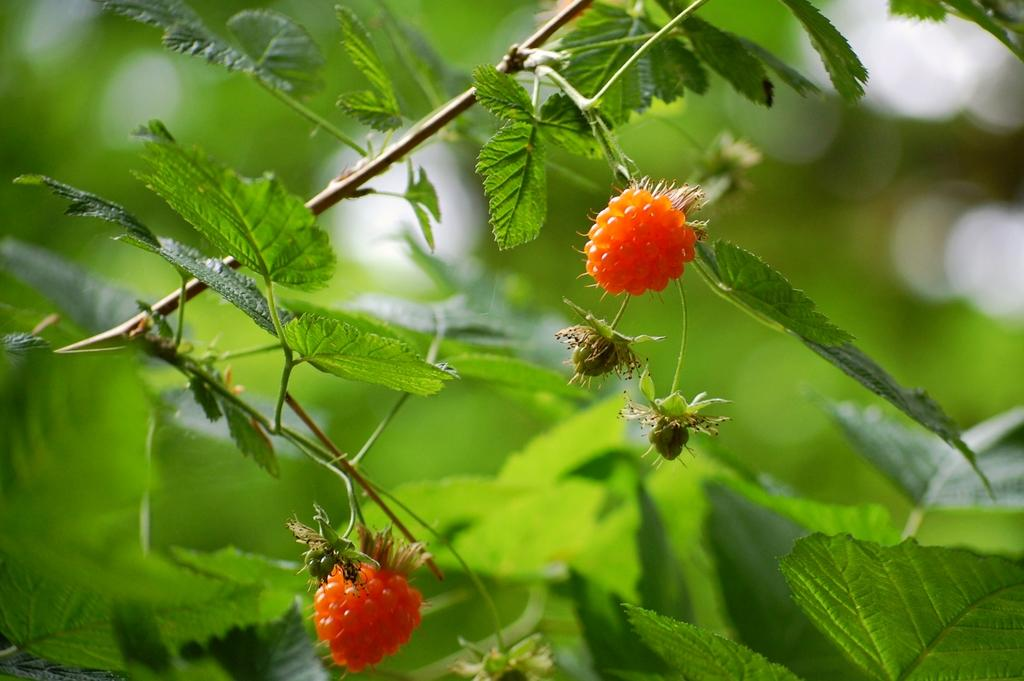What is present on the fruit in the image? There is an insect on a fruit in the image. What color are the fruits in the image? The fruits in the image are orange in color. What can be seen in the background of the image? There are plants in green color in the background of the image. What type of linen is being used to cover the fruit in the image? There is no linen present in the image, and the fruit is not covered. 